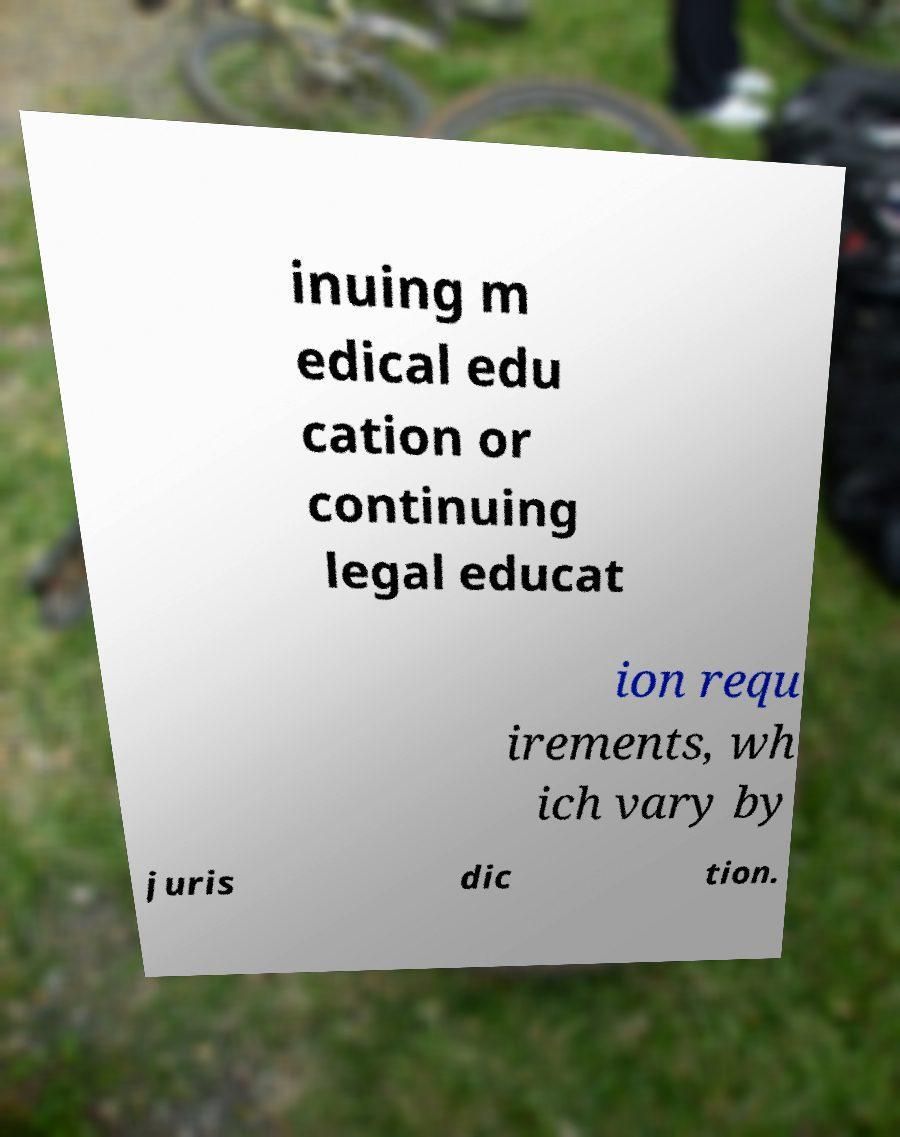Could you assist in decoding the text presented in this image and type it out clearly? inuing m edical edu cation or continuing legal educat ion requ irements, wh ich vary by juris dic tion. 